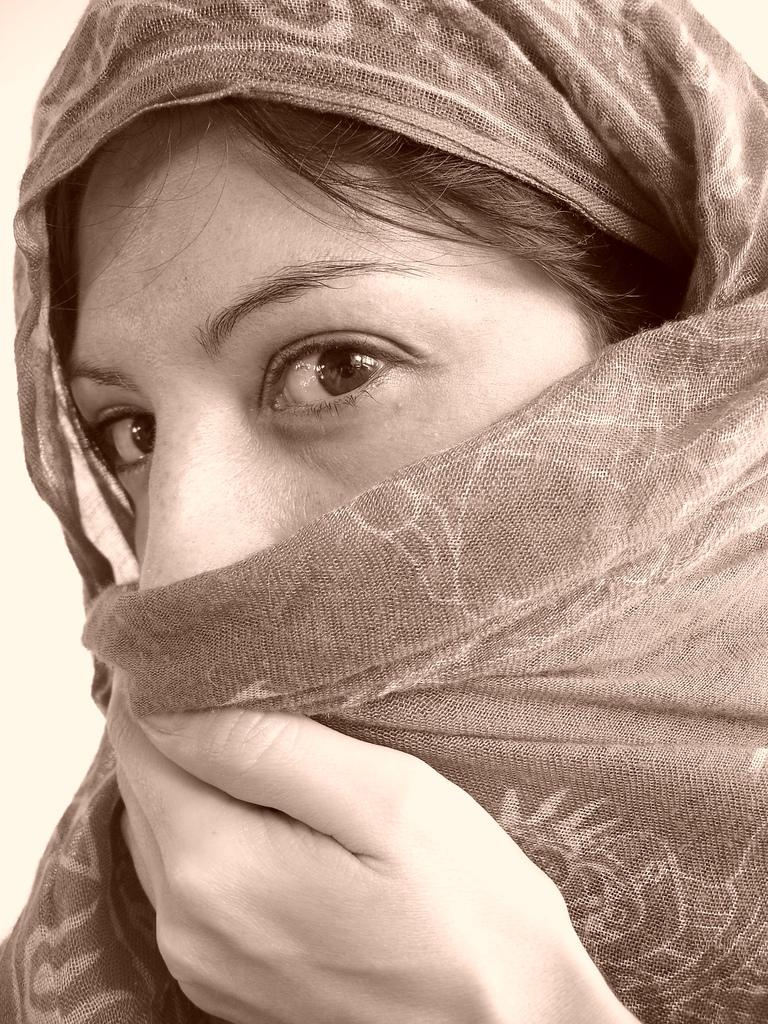What is the main subject of the image? The main subject of the image is a woman's face. How is the woman's face covered in the image? The woman's face is covered with a cloth. Can you describe the cloth that covers the woman's face? The cloth has a design on it. What type of cub can be seen playing with the dinosaurs in the image? There are no cubs or dinosaurs present in the image; it features a woman's face covered with a cloth. 